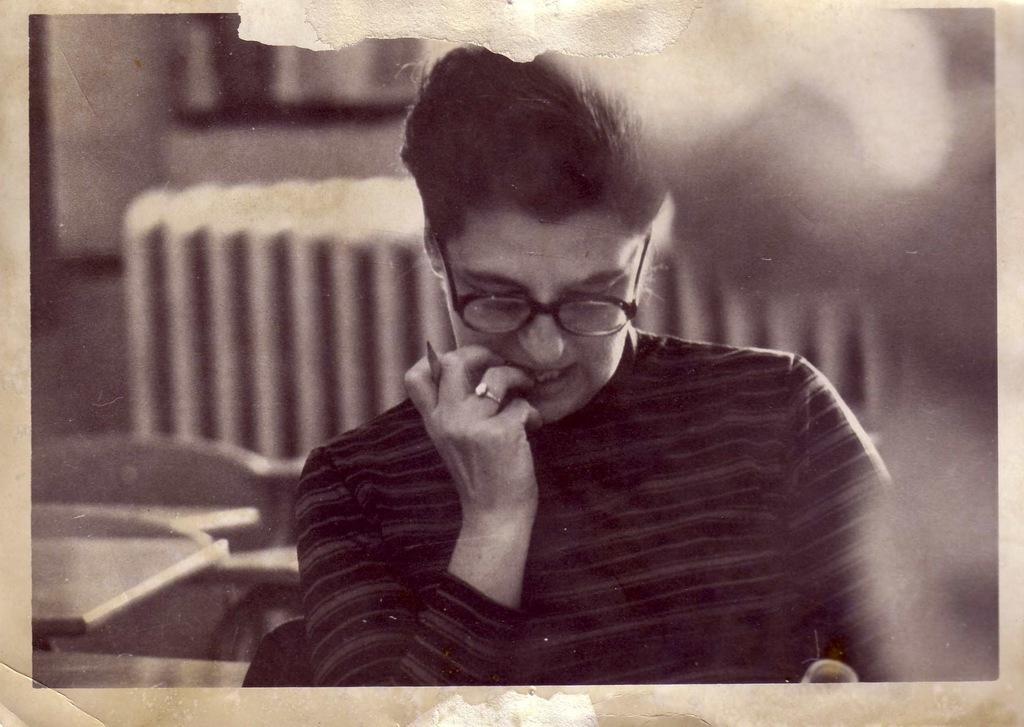In one or two sentences, can you explain what this image depicts? In the image we can see a photo. In the photo a person is sitting and holding a pen. Behind him there are some chairs and tables. Background of the image is blur. 